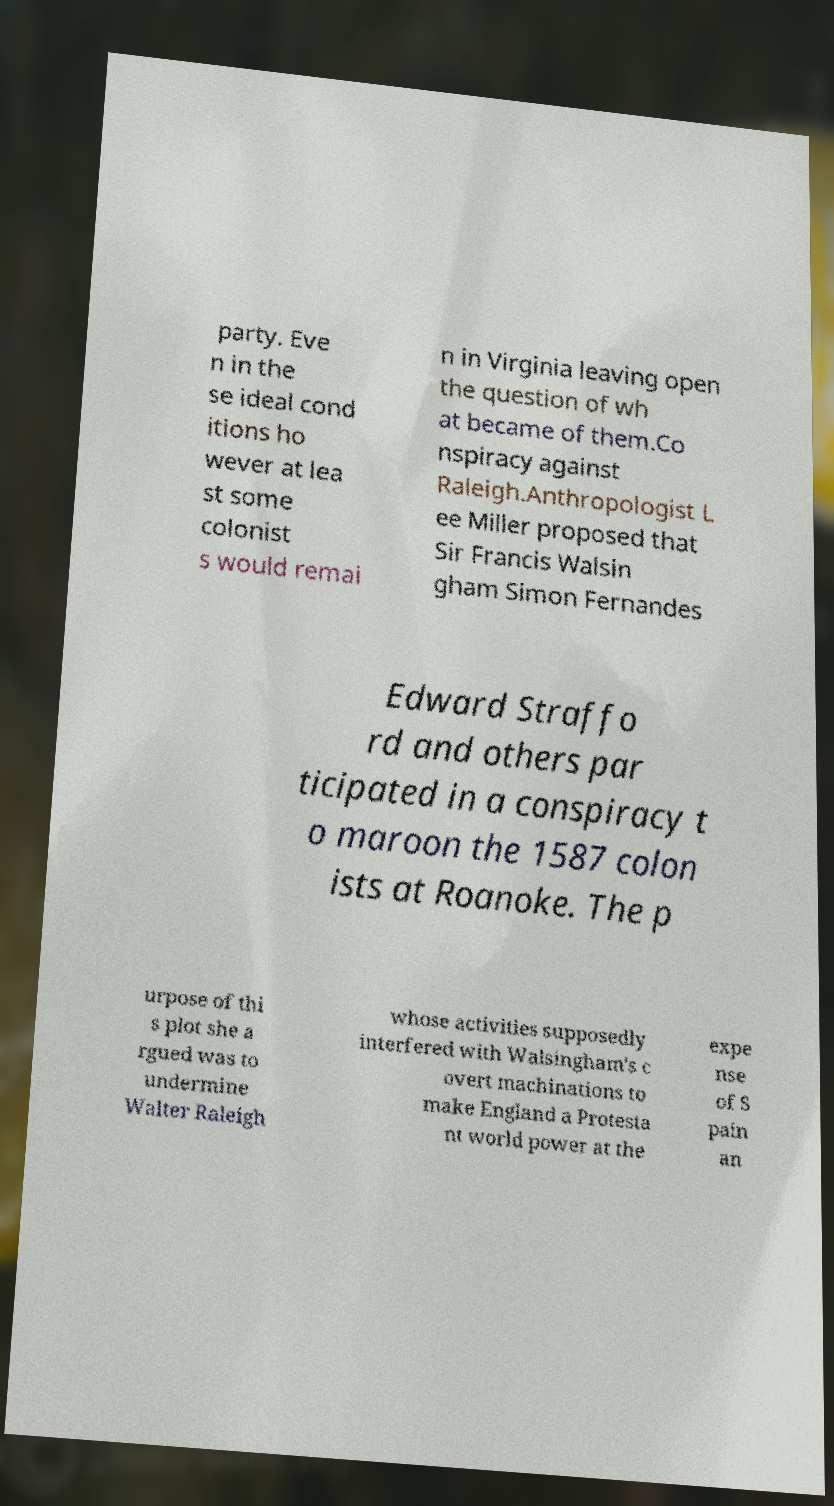Can you read and provide the text displayed in the image?This photo seems to have some interesting text. Can you extract and type it out for me? party. Eve n in the se ideal cond itions ho wever at lea st some colonist s would remai n in Virginia leaving open the question of wh at became of them.Co nspiracy against Raleigh.Anthropologist L ee Miller proposed that Sir Francis Walsin gham Simon Fernandes Edward Straffo rd and others par ticipated in a conspiracy t o maroon the 1587 colon ists at Roanoke. The p urpose of thi s plot she a rgued was to undermine Walter Raleigh whose activities supposedly interfered with Walsingham's c overt machinations to make England a Protesta nt world power at the expe nse of S pain an 